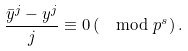<formula> <loc_0><loc_0><loc_500><loc_500>\frac { \bar { y } ^ { j } - y ^ { j } } { j } \equiv 0 \left ( \mod p ^ { s } \right ) .</formula> 